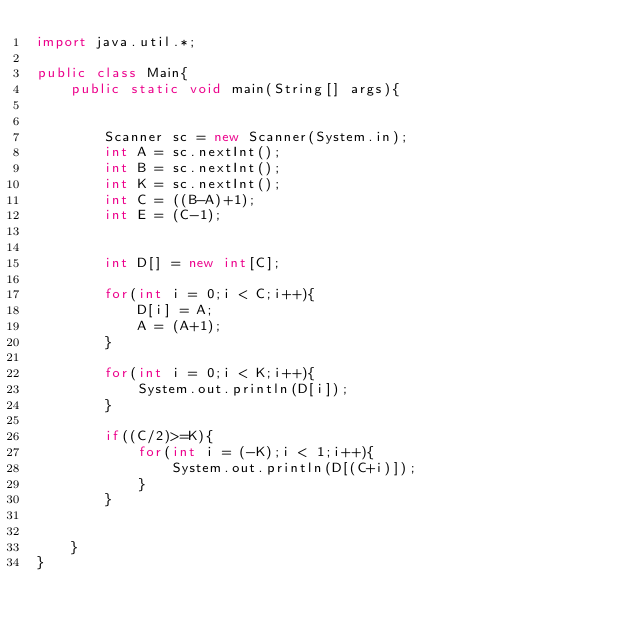<code> <loc_0><loc_0><loc_500><loc_500><_Java_>import java.util.*;

public class Main{
    public static void main(String[] args){


        Scanner sc = new Scanner(System.in);
        int A = sc.nextInt();
        int B = sc.nextInt();
        int K = sc.nextInt();
        int C = ((B-A)+1);
        int E = (C-1);
        

        int D[] = new int[C];

        for(int i = 0;i < C;i++){
            D[i] = A;
            A = (A+1);
        }

        for(int i = 0;i < K;i++){
            System.out.println(D[i]);
        }

        if((C/2)>=K){
            for(int i = (-K);i < 1;i++){
                System.out.println(D[(C+i)]);
            }
        }
            
        
    }
}</code> 